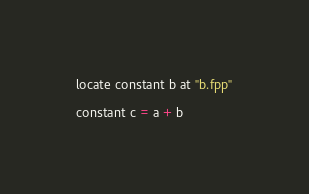<code> <loc_0><loc_0><loc_500><loc_500><_FORTRAN_>locate constant b at "b.fpp"

constant c = a + b
</code> 